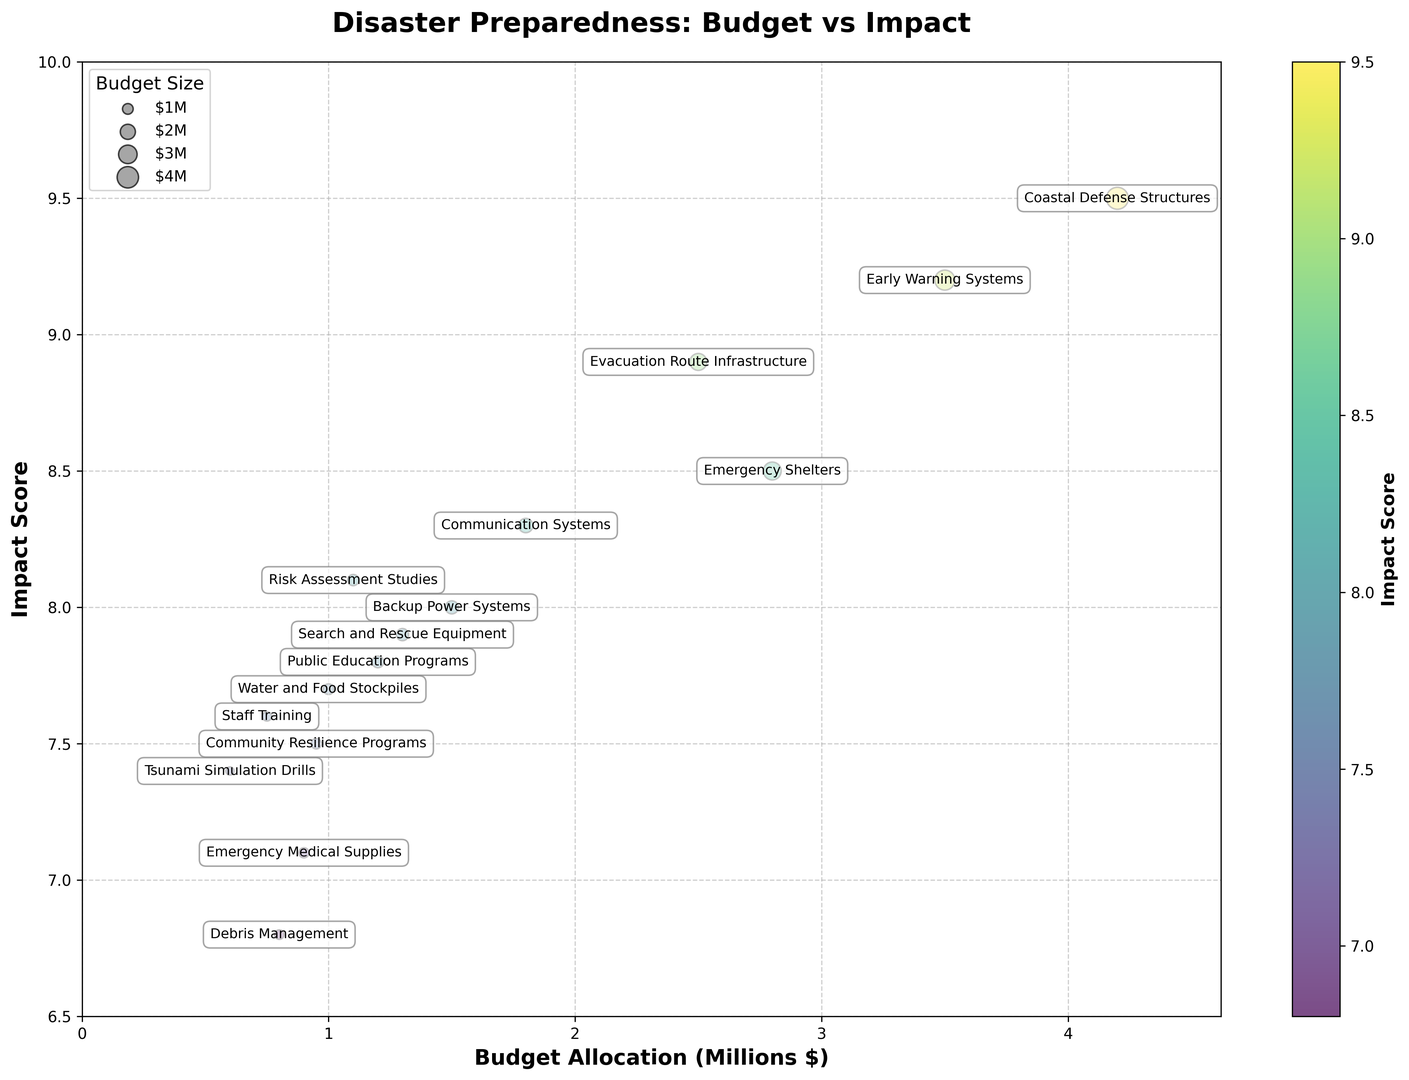Which category has the highest impact score? The category with the highest position on the y-axis will have the highest impact score.
Answer: Coastal Defense Structures Which category has the lowest budget allocation? The smallest bubble on the x-axis represents the lowest budget allocation.
Answer: Tsunami Simulation Drills How much larger is the budget for Coastal Defense Structures compared to Emergency Medical Supplies? The budget for Coastal Defense Structures is $4.2M, and for Emergency Medical Supplies, it is $0.9M. The difference is $4.2M - $0.9M.
Answer: $3.3M What is the average impact score for all categories? Sum all the impact scores and divide by the number of categories. The sum is 9.2 + 8.5 + 7.8 + 8.9 + 8.3 + 7.1 + 9.5 + 7.6 + 7.4 + 8.1 + 8.0 + 7.9 + 7.7 + 6.8 + 7.5 = 123.2. There are 15 categories, so the average is 123.2 / 15.
Answer: 8.21 Which categories have an impact score greater than 8.5? Look for categories where the y-axis value is greater than 8.5. These are Early Warning Systems, Coastal Defense Structures, and Evacuation Route Infrastructure.
Answer: Early Warning Systems, Coastal Defense Structures, Evacuation Route Infrastructure What is the total budget allocation for categories with an impact score over 8? Sum the budget values for categories with an impact score greater than 8. The categories are Early Warning Systems ($3.5M), Emergency Shelters ($2.8M), Evacuation Route Infrastructure ($2.5M), Communication Systems ($1.8M), Risk Assessment Studies ($1.1M), Backup Power Systems ($1.5M), and Search and Rescue Equipment ($1.3M). The sum is $3.5M + $2.8M + $2.5M + $1.8M + $1.1M + $1.5M + $1.3M.
Answer: $14.5M Which categories fall between $1M to $2M in budget allocation and have an impact score above 7? Find categories where the position on the x-axis is between $1M and $2M, and the y-axis position is above 7. These categories are Communication Systems, Backup Power Systems, Search and Rescue Equipment, Water and Food Stockpiles, and Risk Assessment Studies.
Answer: Communication Systems, Backup Power Systems, Search and Rescue Equipment, Water and Food Stockpiles, Risk Assessment Studies Are there any categories with both a low budget (less than $1M) and a high impact score (greater than 7)? Look for bubbles with x values less than $1M and y values greater than 7. These are Staff Training, Tsunami Simulation Drills, and Community Resilience Programs.
Answer: Staff Training, Tsunami Simulation Drills, Community Resilience Programs 